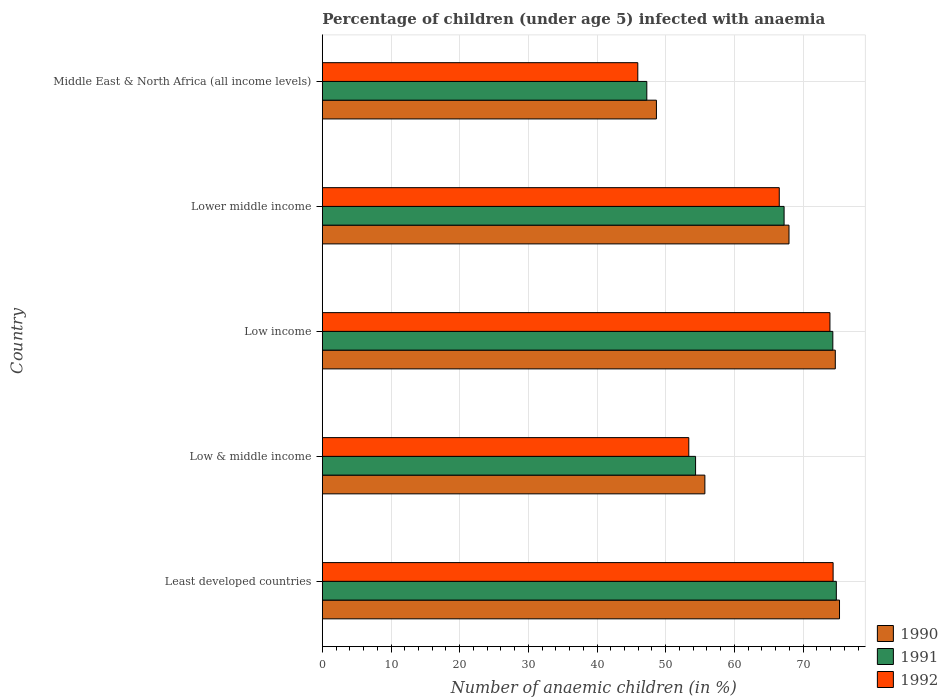How many different coloured bars are there?
Give a very brief answer. 3. How many bars are there on the 5th tick from the top?
Provide a short and direct response. 3. How many bars are there on the 1st tick from the bottom?
Offer a terse response. 3. What is the percentage of children infected with anaemia in in 1992 in Lower middle income?
Your answer should be compact. 66.53. Across all countries, what is the maximum percentage of children infected with anaemia in in 1990?
Ensure brevity in your answer.  75.31. Across all countries, what is the minimum percentage of children infected with anaemia in in 1991?
Your response must be concise. 47.25. In which country was the percentage of children infected with anaemia in in 1991 maximum?
Make the answer very short. Least developed countries. In which country was the percentage of children infected with anaemia in in 1990 minimum?
Ensure brevity in your answer.  Middle East & North Africa (all income levels). What is the total percentage of children infected with anaemia in in 1990 in the graph?
Ensure brevity in your answer.  322.3. What is the difference between the percentage of children infected with anaemia in in 1992 in Least developed countries and that in Low & middle income?
Provide a succinct answer. 21.01. What is the difference between the percentage of children infected with anaemia in in 1991 in Lower middle income and the percentage of children infected with anaemia in in 1992 in Least developed countries?
Offer a terse response. -7.14. What is the average percentage of children infected with anaemia in in 1992 per country?
Offer a very short reply. 62.82. What is the difference between the percentage of children infected with anaemia in in 1991 and percentage of children infected with anaemia in in 1990 in Low income?
Provide a short and direct response. -0.36. In how many countries, is the percentage of children infected with anaemia in in 1990 greater than 36 %?
Make the answer very short. 5. What is the ratio of the percentage of children infected with anaemia in in 1992 in Low & middle income to that in Middle East & North Africa (all income levels)?
Provide a succinct answer. 1.16. Is the percentage of children infected with anaemia in in 1992 in Least developed countries less than that in Middle East & North Africa (all income levels)?
Ensure brevity in your answer.  No. Is the difference between the percentage of children infected with anaemia in in 1991 in Low & middle income and Middle East & North Africa (all income levels) greater than the difference between the percentage of children infected with anaemia in in 1990 in Low & middle income and Middle East & North Africa (all income levels)?
Provide a succinct answer. Yes. What is the difference between the highest and the second highest percentage of children infected with anaemia in in 1992?
Offer a very short reply. 0.46. What is the difference between the highest and the lowest percentage of children infected with anaemia in in 1991?
Your answer should be very brief. 27.6. In how many countries, is the percentage of children infected with anaemia in in 1991 greater than the average percentage of children infected with anaemia in in 1991 taken over all countries?
Your answer should be very brief. 3. Is it the case that in every country, the sum of the percentage of children infected with anaemia in in 1990 and percentage of children infected with anaemia in in 1991 is greater than the percentage of children infected with anaemia in in 1992?
Keep it short and to the point. Yes. How many bars are there?
Keep it short and to the point. 15. What is the title of the graph?
Give a very brief answer. Percentage of children (under age 5) infected with anaemia. What is the label or title of the X-axis?
Your answer should be compact. Number of anaemic children (in %). What is the label or title of the Y-axis?
Keep it short and to the point. Country. What is the Number of anaemic children (in %) of 1990 in Least developed countries?
Offer a terse response. 75.31. What is the Number of anaemic children (in %) of 1991 in Least developed countries?
Provide a succinct answer. 74.84. What is the Number of anaemic children (in %) in 1992 in Least developed countries?
Provide a succinct answer. 74.38. What is the Number of anaemic children (in %) in 1990 in Low & middle income?
Ensure brevity in your answer.  55.7. What is the Number of anaemic children (in %) in 1991 in Low & middle income?
Your answer should be very brief. 54.35. What is the Number of anaemic children (in %) in 1992 in Low & middle income?
Your answer should be very brief. 53.36. What is the Number of anaemic children (in %) in 1990 in Low income?
Provide a short and direct response. 74.69. What is the Number of anaemic children (in %) of 1991 in Low income?
Your answer should be very brief. 74.33. What is the Number of anaemic children (in %) of 1992 in Low income?
Give a very brief answer. 73.91. What is the Number of anaemic children (in %) in 1990 in Lower middle income?
Make the answer very short. 67.95. What is the Number of anaemic children (in %) of 1991 in Lower middle income?
Keep it short and to the point. 67.24. What is the Number of anaemic children (in %) in 1992 in Lower middle income?
Your answer should be compact. 66.53. What is the Number of anaemic children (in %) in 1990 in Middle East & North Africa (all income levels)?
Ensure brevity in your answer.  48.65. What is the Number of anaemic children (in %) in 1991 in Middle East & North Africa (all income levels)?
Make the answer very short. 47.25. What is the Number of anaemic children (in %) of 1992 in Middle East & North Africa (all income levels)?
Give a very brief answer. 45.93. Across all countries, what is the maximum Number of anaemic children (in %) of 1990?
Give a very brief answer. 75.31. Across all countries, what is the maximum Number of anaemic children (in %) of 1991?
Offer a very short reply. 74.84. Across all countries, what is the maximum Number of anaemic children (in %) in 1992?
Your answer should be very brief. 74.38. Across all countries, what is the minimum Number of anaemic children (in %) of 1990?
Offer a terse response. 48.65. Across all countries, what is the minimum Number of anaemic children (in %) in 1991?
Offer a very short reply. 47.25. Across all countries, what is the minimum Number of anaemic children (in %) in 1992?
Give a very brief answer. 45.93. What is the total Number of anaemic children (in %) in 1990 in the graph?
Your response must be concise. 322.3. What is the total Number of anaemic children (in %) in 1991 in the graph?
Make the answer very short. 318.01. What is the total Number of anaemic children (in %) in 1992 in the graph?
Your answer should be compact. 314.12. What is the difference between the Number of anaemic children (in %) of 1990 in Least developed countries and that in Low & middle income?
Ensure brevity in your answer.  19.6. What is the difference between the Number of anaemic children (in %) in 1991 in Least developed countries and that in Low & middle income?
Make the answer very short. 20.49. What is the difference between the Number of anaemic children (in %) in 1992 in Least developed countries and that in Low & middle income?
Ensure brevity in your answer.  21.01. What is the difference between the Number of anaemic children (in %) in 1990 in Least developed countries and that in Low income?
Make the answer very short. 0.61. What is the difference between the Number of anaemic children (in %) in 1991 in Least developed countries and that in Low income?
Your response must be concise. 0.51. What is the difference between the Number of anaemic children (in %) in 1992 in Least developed countries and that in Low income?
Offer a very short reply. 0.46. What is the difference between the Number of anaemic children (in %) of 1990 in Least developed countries and that in Lower middle income?
Your answer should be compact. 7.35. What is the difference between the Number of anaemic children (in %) of 1991 in Least developed countries and that in Lower middle income?
Your answer should be very brief. 7.6. What is the difference between the Number of anaemic children (in %) of 1992 in Least developed countries and that in Lower middle income?
Offer a terse response. 7.84. What is the difference between the Number of anaemic children (in %) in 1990 in Least developed countries and that in Middle East & North Africa (all income levels)?
Your answer should be compact. 26.66. What is the difference between the Number of anaemic children (in %) in 1991 in Least developed countries and that in Middle East & North Africa (all income levels)?
Ensure brevity in your answer.  27.6. What is the difference between the Number of anaemic children (in %) in 1992 in Least developed countries and that in Middle East & North Africa (all income levels)?
Offer a terse response. 28.44. What is the difference between the Number of anaemic children (in %) of 1990 in Low & middle income and that in Low income?
Give a very brief answer. -18.99. What is the difference between the Number of anaemic children (in %) of 1991 in Low & middle income and that in Low income?
Offer a terse response. -19.99. What is the difference between the Number of anaemic children (in %) in 1992 in Low & middle income and that in Low income?
Your response must be concise. -20.55. What is the difference between the Number of anaemic children (in %) of 1990 in Low & middle income and that in Lower middle income?
Provide a short and direct response. -12.25. What is the difference between the Number of anaemic children (in %) of 1991 in Low & middle income and that in Lower middle income?
Your answer should be very brief. -12.89. What is the difference between the Number of anaemic children (in %) in 1992 in Low & middle income and that in Lower middle income?
Provide a short and direct response. -13.17. What is the difference between the Number of anaemic children (in %) of 1990 in Low & middle income and that in Middle East & North Africa (all income levels)?
Make the answer very short. 7.06. What is the difference between the Number of anaemic children (in %) in 1991 in Low & middle income and that in Middle East & North Africa (all income levels)?
Your answer should be compact. 7.1. What is the difference between the Number of anaemic children (in %) of 1992 in Low & middle income and that in Middle East & North Africa (all income levels)?
Provide a short and direct response. 7.43. What is the difference between the Number of anaemic children (in %) of 1990 in Low income and that in Lower middle income?
Ensure brevity in your answer.  6.74. What is the difference between the Number of anaemic children (in %) in 1991 in Low income and that in Lower middle income?
Your answer should be very brief. 7.1. What is the difference between the Number of anaemic children (in %) of 1992 in Low income and that in Lower middle income?
Make the answer very short. 7.38. What is the difference between the Number of anaemic children (in %) of 1990 in Low income and that in Middle East & North Africa (all income levels)?
Give a very brief answer. 26.05. What is the difference between the Number of anaemic children (in %) of 1991 in Low income and that in Middle East & North Africa (all income levels)?
Offer a very short reply. 27.09. What is the difference between the Number of anaemic children (in %) in 1992 in Low income and that in Middle East & North Africa (all income levels)?
Keep it short and to the point. 27.98. What is the difference between the Number of anaemic children (in %) of 1990 in Lower middle income and that in Middle East & North Africa (all income levels)?
Offer a terse response. 19.31. What is the difference between the Number of anaemic children (in %) in 1991 in Lower middle income and that in Middle East & North Africa (all income levels)?
Provide a short and direct response. 19.99. What is the difference between the Number of anaemic children (in %) in 1992 in Lower middle income and that in Middle East & North Africa (all income levels)?
Provide a short and direct response. 20.6. What is the difference between the Number of anaemic children (in %) of 1990 in Least developed countries and the Number of anaemic children (in %) of 1991 in Low & middle income?
Keep it short and to the point. 20.96. What is the difference between the Number of anaemic children (in %) in 1990 in Least developed countries and the Number of anaemic children (in %) in 1992 in Low & middle income?
Give a very brief answer. 21.94. What is the difference between the Number of anaemic children (in %) in 1991 in Least developed countries and the Number of anaemic children (in %) in 1992 in Low & middle income?
Your answer should be compact. 21.48. What is the difference between the Number of anaemic children (in %) of 1990 in Least developed countries and the Number of anaemic children (in %) of 1991 in Low income?
Make the answer very short. 0.97. What is the difference between the Number of anaemic children (in %) of 1990 in Least developed countries and the Number of anaemic children (in %) of 1992 in Low income?
Keep it short and to the point. 1.39. What is the difference between the Number of anaemic children (in %) in 1991 in Least developed countries and the Number of anaemic children (in %) in 1992 in Low income?
Offer a terse response. 0.93. What is the difference between the Number of anaemic children (in %) of 1990 in Least developed countries and the Number of anaemic children (in %) of 1991 in Lower middle income?
Provide a succinct answer. 8.07. What is the difference between the Number of anaemic children (in %) of 1990 in Least developed countries and the Number of anaemic children (in %) of 1992 in Lower middle income?
Make the answer very short. 8.77. What is the difference between the Number of anaemic children (in %) of 1991 in Least developed countries and the Number of anaemic children (in %) of 1992 in Lower middle income?
Your answer should be very brief. 8.31. What is the difference between the Number of anaemic children (in %) of 1990 in Least developed countries and the Number of anaemic children (in %) of 1991 in Middle East & North Africa (all income levels)?
Provide a succinct answer. 28.06. What is the difference between the Number of anaemic children (in %) in 1990 in Least developed countries and the Number of anaemic children (in %) in 1992 in Middle East & North Africa (all income levels)?
Provide a short and direct response. 29.37. What is the difference between the Number of anaemic children (in %) of 1991 in Least developed countries and the Number of anaemic children (in %) of 1992 in Middle East & North Africa (all income levels)?
Provide a short and direct response. 28.91. What is the difference between the Number of anaemic children (in %) of 1990 in Low & middle income and the Number of anaemic children (in %) of 1991 in Low income?
Keep it short and to the point. -18.63. What is the difference between the Number of anaemic children (in %) in 1990 in Low & middle income and the Number of anaemic children (in %) in 1992 in Low income?
Your answer should be compact. -18.21. What is the difference between the Number of anaemic children (in %) of 1991 in Low & middle income and the Number of anaemic children (in %) of 1992 in Low income?
Provide a short and direct response. -19.56. What is the difference between the Number of anaemic children (in %) in 1990 in Low & middle income and the Number of anaemic children (in %) in 1991 in Lower middle income?
Offer a very short reply. -11.54. What is the difference between the Number of anaemic children (in %) of 1990 in Low & middle income and the Number of anaemic children (in %) of 1992 in Lower middle income?
Offer a terse response. -10.83. What is the difference between the Number of anaemic children (in %) of 1991 in Low & middle income and the Number of anaemic children (in %) of 1992 in Lower middle income?
Provide a short and direct response. -12.19. What is the difference between the Number of anaemic children (in %) in 1990 in Low & middle income and the Number of anaemic children (in %) in 1991 in Middle East & North Africa (all income levels)?
Your answer should be very brief. 8.46. What is the difference between the Number of anaemic children (in %) of 1990 in Low & middle income and the Number of anaemic children (in %) of 1992 in Middle East & North Africa (all income levels)?
Keep it short and to the point. 9.77. What is the difference between the Number of anaemic children (in %) in 1991 in Low & middle income and the Number of anaemic children (in %) in 1992 in Middle East & North Africa (all income levels)?
Make the answer very short. 8.41. What is the difference between the Number of anaemic children (in %) in 1990 in Low income and the Number of anaemic children (in %) in 1991 in Lower middle income?
Ensure brevity in your answer.  7.46. What is the difference between the Number of anaemic children (in %) in 1990 in Low income and the Number of anaemic children (in %) in 1992 in Lower middle income?
Offer a terse response. 8.16. What is the difference between the Number of anaemic children (in %) in 1991 in Low income and the Number of anaemic children (in %) in 1992 in Lower middle income?
Your answer should be compact. 7.8. What is the difference between the Number of anaemic children (in %) in 1990 in Low income and the Number of anaemic children (in %) in 1991 in Middle East & North Africa (all income levels)?
Your answer should be very brief. 27.45. What is the difference between the Number of anaemic children (in %) of 1990 in Low income and the Number of anaemic children (in %) of 1992 in Middle East & North Africa (all income levels)?
Your answer should be compact. 28.76. What is the difference between the Number of anaemic children (in %) of 1991 in Low income and the Number of anaemic children (in %) of 1992 in Middle East & North Africa (all income levels)?
Your response must be concise. 28.4. What is the difference between the Number of anaemic children (in %) in 1990 in Lower middle income and the Number of anaemic children (in %) in 1991 in Middle East & North Africa (all income levels)?
Provide a short and direct response. 20.71. What is the difference between the Number of anaemic children (in %) in 1990 in Lower middle income and the Number of anaemic children (in %) in 1992 in Middle East & North Africa (all income levels)?
Make the answer very short. 22.02. What is the difference between the Number of anaemic children (in %) in 1991 in Lower middle income and the Number of anaemic children (in %) in 1992 in Middle East & North Africa (all income levels)?
Give a very brief answer. 21.3. What is the average Number of anaemic children (in %) in 1990 per country?
Your answer should be compact. 64.46. What is the average Number of anaemic children (in %) of 1991 per country?
Keep it short and to the point. 63.6. What is the average Number of anaemic children (in %) in 1992 per country?
Offer a very short reply. 62.82. What is the difference between the Number of anaemic children (in %) in 1990 and Number of anaemic children (in %) in 1991 in Least developed countries?
Give a very brief answer. 0.46. What is the difference between the Number of anaemic children (in %) of 1990 and Number of anaemic children (in %) of 1992 in Least developed countries?
Provide a succinct answer. 0.93. What is the difference between the Number of anaemic children (in %) in 1991 and Number of anaemic children (in %) in 1992 in Least developed countries?
Your answer should be very brief. 0.47. What is the difference between the Number of anaemic children (in %) in 1990 and Number of anaemic children (in %) in 1991 in Low & middle income?
Provide a succinct answer. 1.36. What is the difference between the Number of anaemic children (in %) of 1990 and Number of anaemic children (in %) of 1992 in Low & middle income?
Keep it short and to the point. 2.34. What is the difference between the Number of anaemic children (in %) of 1991 and Number of anaemic children (in %) of 1992 in Low & middle income?
Your answer should be compact. 0.99. What is the difference between the Number of anaemic children (in %) in 1990 and Number of anaemic children (in %) in 1991 in Low income?
Offer a very short reply. 0.36. What is the difference between the Number of anaemic children (in %) of 1990 and Number of anaemic children (in %) of 1992 in Low income?
Provide a succinct answer. 0.78. What is the difference between the Number of anaemic children (in %) in 1991 and Number of anaemic children (in %) in 1992 in Low income?
Provide a short and direct response. 0.42. What is the difference between the Number of anaemic children (in %) of 1990 and Number of anaemic children (in %) of 1991 in Lower middle income?
Your response must be concise. 0.71. What is the difference between the Number of anaemic children (in %) in 1990 and Number of anaemic children (in %) in 1992 in Lower middle income?
Your answer should be compact. 1.42. What is the difference between the Number of anaemic children (in %) in 1991 and Number of anaemic children (in %) in 1992 in Lower middle income?
Ensure brevity in your answer.  0.7. What is the difference between the Number of anaemic children (in %) of 1990 and Number of anaemic children (in %) of 1991 in Middle East & North Africa (all income levels)?
Give a very brief answer. 1.4. What is the difference between the Number of anaemic children (in %) of 1990 and Number of anaemic children (in %) of 1992 in Middle East & North Africa (all income levels)?
Your response must be concise. 2.71. What is the difference between the Number of anaemic children (in %) of 1991 and Number of anaemic children (in %) of 1992 in Middle East & North Africa (all income levels)?
Offer a very short reply. 1.31. What is the ratio of the Number of anaemic children (in %) in 1990 in Least developed countries to that in Low & middle income?
Ensure brevity in your answer.  1.35. What is the ratio of the Number of anaemic children (in %) in 1991 in Least developed countries to that in Low & middle income?
Keep it short and to the point. 1.38. What is the ratio of the Number of anaemic children (in %) in 1992 in Least developed countries to that in Low & middle income?
Provide a short and direct response. 1.39. What is the ratio of the Number of anaemic children (in %) in 1990 in Least developed countries to that in Low income?
Your response must be concise. 1.01. What is the ratio of the Number of anaemic children (in %) of 1991 in Least developed countries to that in Low income?
Your answer should be compact. 1.01. What is the ratio of the Number of anaemic children (in %) of 1992 in Least developed countries to that in Low income?
Your answer should be very brief. 1.01. What is the ratio of the Number of anaemic children (in %) of 1990 in Least developed countries to that in Lower middle income?
Ensure brevity in your answer.  1.11. What is the ratio of the Number of anaemic children (in %) in 1991 in Least developed countries to that in Lower middle income?
Your answer should be compact. 1.11. What is the ratio of the Number of anaemic children (in %) of 1992 in Least developed countries to that in Lower middle income?
Offer a terse response. 1.12. What is the ratio of the Number of anaemic children (in %) of 1990 in Least developed countries to that in Middle East & North Africa (all income levels)?
Your answer should be compact. 1.55. What is the ratio of the Number of anaemic children (in %) of 1991 in Least developed countries to that in Middle East & North Africa (all income levels)?
Ensure brevity in your answer.  1.58. What is the ratio of the Number of anaemic children (in %) in 1992 in Least developed countries to that in Middle East & North Africa (all income levels)?
Offer a very short reply. 1.62. What is the ratio of the Number of anaemic children (in %) of 1990 in Low & middle income to that in Low income?
Your answer should be compact. 0.75. What is the ratio of the Number of anaemic children (in %) of 1991 in Low & middle income to that in Low income?
Make the answer very short. 0.73. What is the ratio of the Number of anaemic children (in %) of 1992 in Low & middle income to that in Low income?
Give a very brief answer. 0.72. What is the ratio of the Number of anaemic children (in %) of 1990 in Low & middle income to that in Lower middle income?
Your answer should be very brief. 0.82. What is the ratio of the Number of anaemic children (in %) in 1991 in Low & middle income to that in Lower middle income?
Make the answer very short. 0.81. What is the ratio of the Number of anaemic children (in %) of 1992 in Low & middle income to that in Lower middle income?
Keep it short and to the point. 0.8. What is the ratio of the Number of anaemic children (in %) of 1990 in Low & middle income to that in Middle East & North Africa (all income levels)?
Ensure brevity in your answer.  1.15. What is the ratio of the Number of anaemic children (in %) in 1991 in Low & middle income to that in Middle East & North Africa (all income levels)?
Make the answer very short. 1.15. What is the ratio of the Number of anaemic children (in %) of 1992 in Low & middle income to that in Middle East & North Africa (all income levels)?
Keep it short and to the point. 1.16. What is the ratio of the Number of anaemic children (in %) in 1990 in Low income to that in Lower middle income?
Make the answer very short. 1.1. What is the ratio of the Number of anaemic children (in %) in 1991 in Low income to that in Lower middle income?
Keep it short and to the point. 1.11. What is the ratio of the Number of anaemic children (in %) of 1992 in Low income to that in Lower middle income?
Your answer should be compact. 1.11. What is the ratio of the Number of anaemic children (in %) of 1990 in Low income to that in Middle East & North Africa (all income levels)?
Provide a short and direct response. 1.54. What is the ratio of the Number of anaemic children (in %) in 1991 in Low income to that in Middle East & North Africa (all income levels)?
Your response must be concise. 1.57. What is the ratio of the Number of anaemic children (in %) in 1992 in Low income to that in Middle East & North Africa (all income levels)?
Offer a very short reply. 1.61. What is the ratio of the Number of anaemic children (in %) in 1990 in Lower middle income to that in Middle East & North Africa (all income levels)?
Your answer should be very brief. 1.4. What is the ratio of the Number of anaemic children (in %) in 1991 in Lower middle income to that in Middle East & North Africa (all income levels)?
Provide a short and direct response. 1.42. What is the ratio of the Number of anaemic children (in %) of 1992 in Lower middle income to that in Middle East & North Africa (all income levels)?
Give a very brief answer. 1.45. What is the difference between the highest and the second highest Number of anaemic children (in %) of 1990?
Give a very brief answer. 0.61. What is the difference between the highest and the second highest Number of anaemic children (in %) in 1991?
Provide a short and direct response. 0.51. What is the difference between the highest and the second highest Number of anaemic children (in %) of 1992?
Your answer should be compact. 0.46. What is the difference between the highest and the lowest Number of anaemic children (in %) in 1990?
Your answer should be compact. 26.66. What is the difference between the highest and the lowest Number of anaemic children (in %) in 1991?
Make the answer very short. 27.6. What is the difference between the highest and the lowest Number of anaemic children (in %) of 1992?
Your response must be concise. 28.44. 